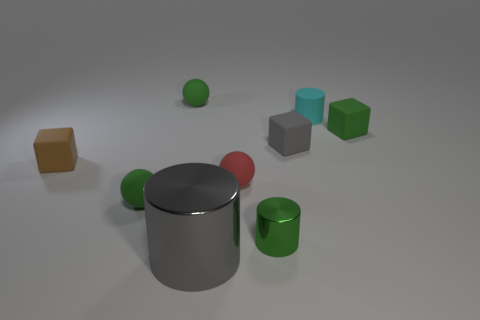There is a thing that is on the right side of the cylinder behind the brown rubber object; what shape is it?
Provide a succinct answer. Cube. Is the number of cylinders that are behind the green cylinder greater than the number of brown matte spheres?
Your response must be concise. Yes. Does the green matte object that is in front of the brown matte object have the same shape as the small red rubber thing?
Give a very brief answer. Yes. Is there a small brown object of the same shape as the small gray rubber object?
Provide a short and direct response. Yes. What number of objects are gray things in front of the red matte thing or small green shiny cylinders?
Give a very brief answer. 2. Is the number of brown rubber blocks greater than the number of green balls?
Your answer should be compact. No. Are there any brown matte cubes that have the same size as the green cylinder?
Give a very brief answer. Yes. How many objects are either small matte blocks behind the brown rubber object or metallic things behind the large object?
Ensure brevity in your answer.  3. There is a tiny rubber cube to the left of the green matte ball that is behind the brown matte block; what is its color?
Keep it short and to the point. Brown. There is a cylinder that is made of the same material as the small brown object; what color is it?
Offer a very short reply. Cyan. 